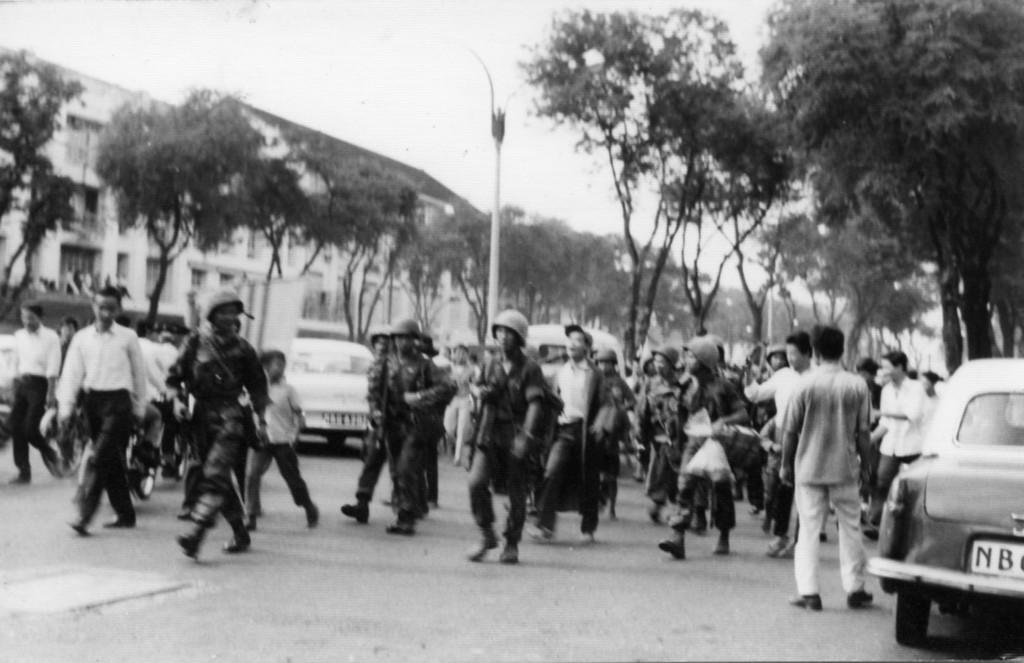Can you describe this image briefly? In the center of the image we can see people walking and some of them are standing. We can see cars on the road. In the background there are trees, pole, buildings and sky. 